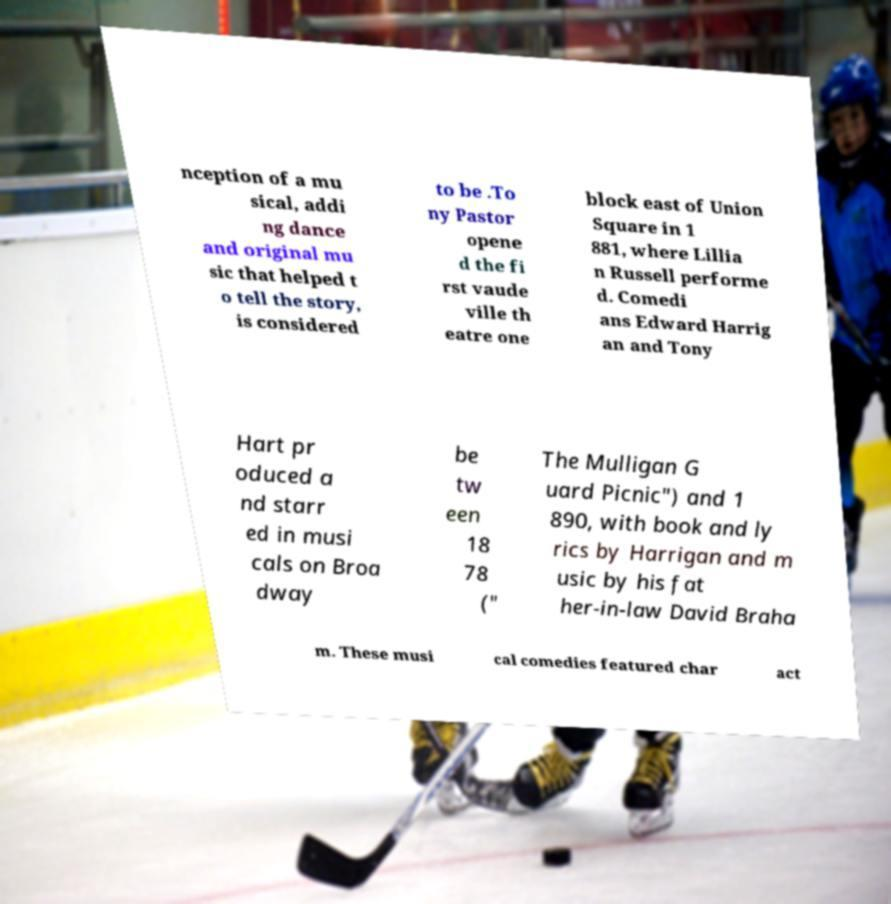Can you read and provide the text displayed in the image?This photo seems to have some interesting text. Can you extract and type it out for me? nception of a mu sical, addi ng dance and original mu sic that helped t o tell the story, is considered to be .To ny Pastor opene d the fi rst vaude ville th eatre one block east of Union Square in 1 881, where Lillia n Russell performe d. Comedi ans Edward Harrig an and Tony Hart pr oduced a nd starr ed in musi cals on Broa dway be tw een 18 78 (" The Mulligan G uard Picnic") and 1 890, with book and ly rics by Harrigan and m usic by his fat her-in-law David Braha m. These musi cal comedies featured char act 